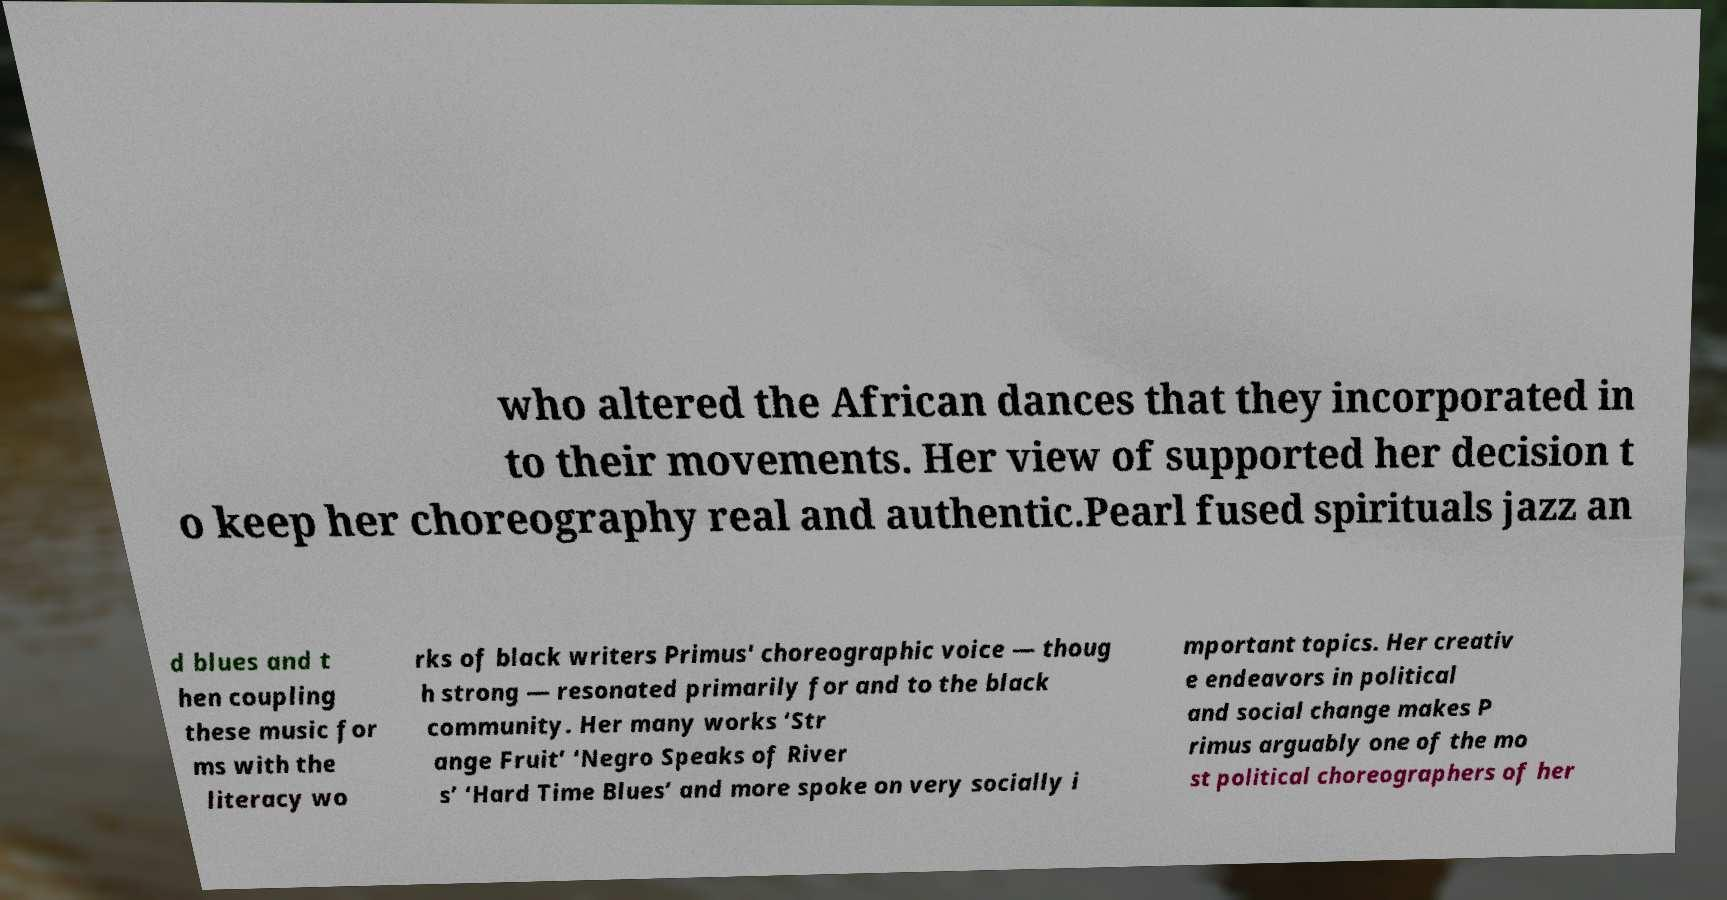Please identify and transcribe the text found in this image. who altered the African dances that they incorporated in to their movements. Her view of supported her decision t o keep her choreography real and authentic.Pearl fused spirituals jazz an d blues and t hen coupling these music for ms with the literacy wo rks of black writers Primus' choreographic voice — thoug h strong — resonated primarily for and to the black community. Her many works ‘Str ange Fruit’ ‘Negro Speaks of River s’ ‘Hard Time Blues’ and more spoke on very socially i mportant topics. Her creativ e endeavors in political and social change makes P rimus arguably one of the mo st political choreographers of her 